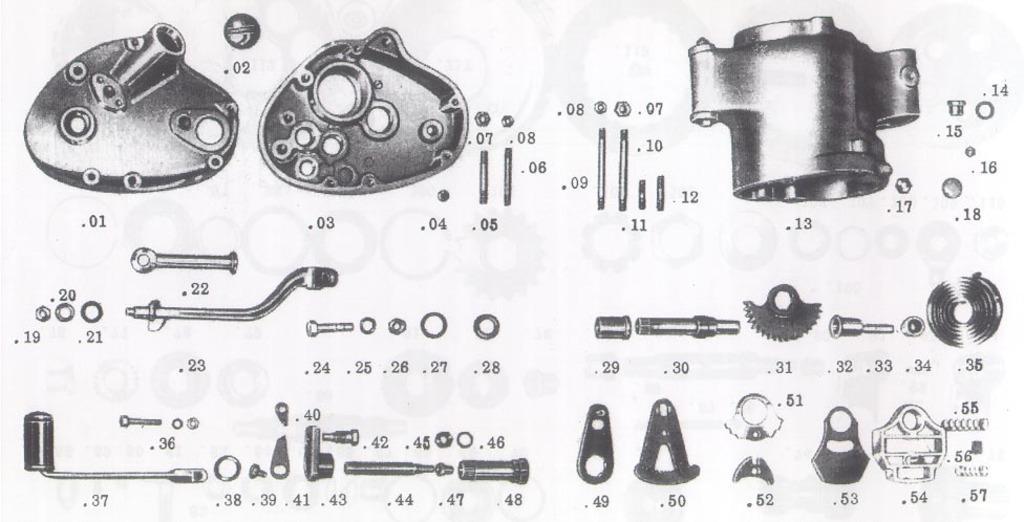Can you describe this image briefly? This is a photo of some mechanical objects drawing. We can also see some numbers. 